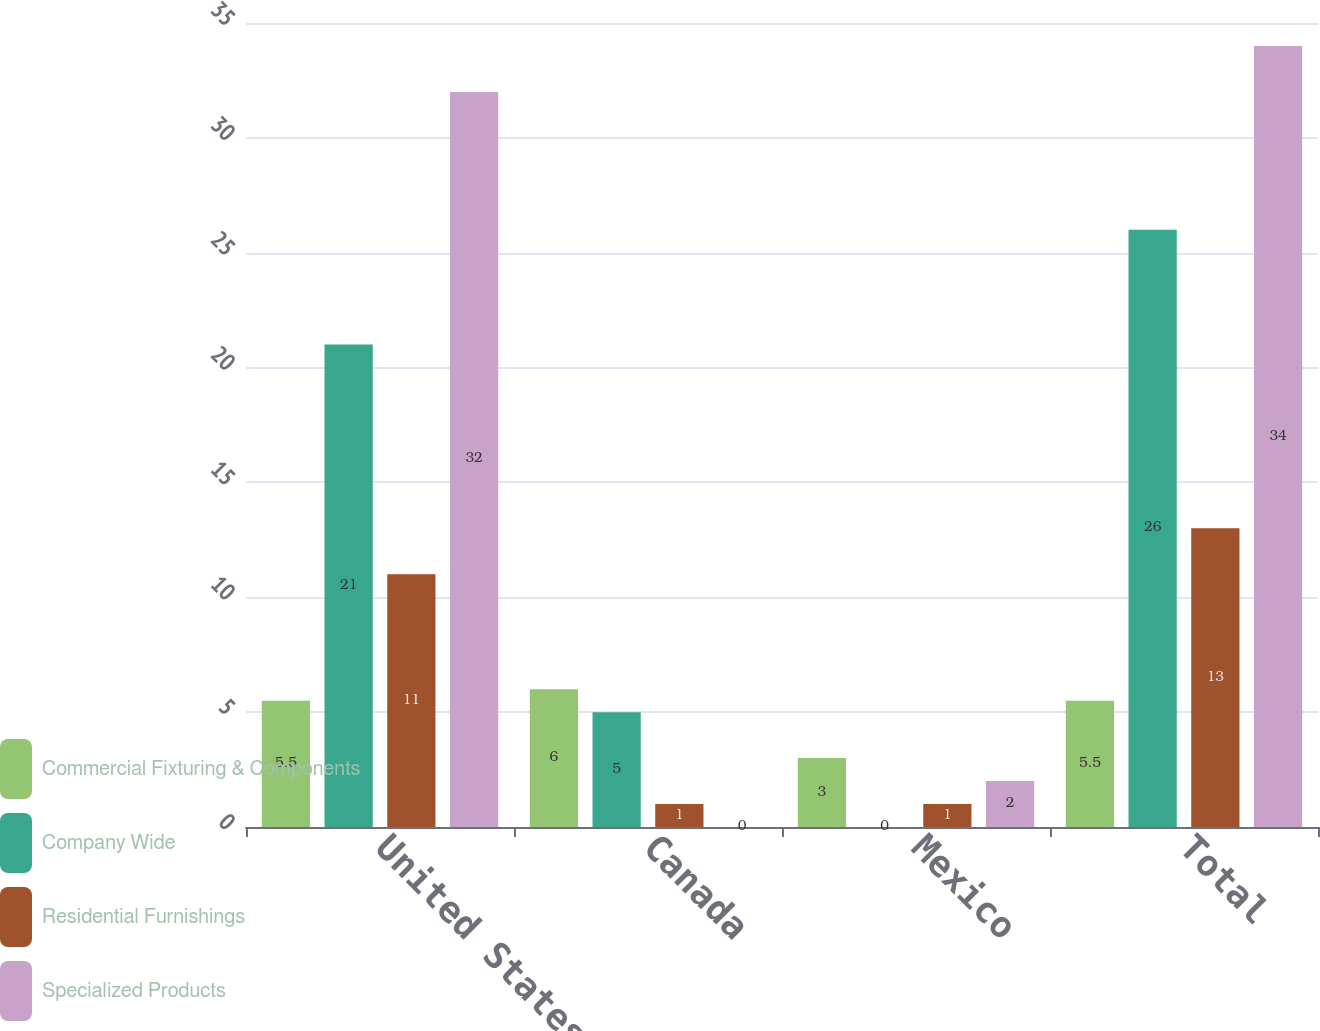Convert chart. <chart><loc_0><loc_0><loc_500><loc_500><stacked_bar_chart><ecel><fcel>United States<fcel>Canada<fcel>Mexico<fcel>Total<nl><fcel>Commercial Fixturing & Components<fcel>5.5<fcel>6<fcel>3<fcel>5.5<nl><fcel>Company Wide<fcel>21<fcel>5<fcel>0<fcel>26<nl><fcel>Residential Furnishings<fcel>11<fcel>1<fcel>1<fcel>13<nl><fcel>Specialized Products<fcel>32<fcel>0<fcel>2<fcel>34<nl></chart> 